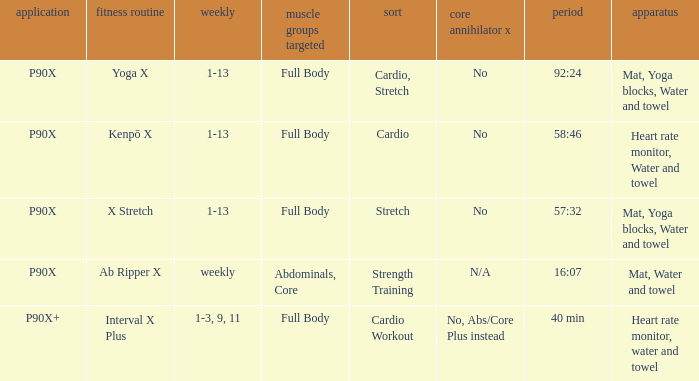What is the week when type is cardio workout? 1-3, 9, 11. 